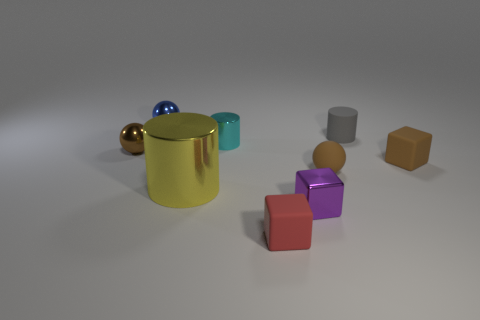What is the material of the tiny gray object that is the same shape as the small cyan object?
Ensure brevity in your answer.  Rubber. There is a small brown thing that is made of the same material as the small blue thing; what is its shape?
Ensure brevity in your answer.  Sphere. What number of other rubber things are the same shape as the red thing?
Your response must be concise. 1. The tiny rubber thing right of the tiny cylinder that is behind the tiny metallic cylinder is what shape?
Your response must be concise. Cube. Do the cylinder in front of the brown shiny thing and the tiny gray matte cylinder have the same size?
Keep it short and to the point. No. How big is the object that is both behind the cyan thing and to the left of the tiny purple thing?
Your answer should be very brief. Small. How many red rubber spheres are the same size as the gray object?
Offer a very short reply. 0. What number of tiny brown rubber objects are right of the sphere that is to the right of the small purple metal object?
Your answer should be very brief. 1. Does the cube that is behind the purple metallic object have the same color as the tiny matte cylinder?
Make the answer very short. No. Is there a thing on the left side of the ball behind the tiny brown ball to the left of the blue metal object?
Offer a terse response. Yes. 